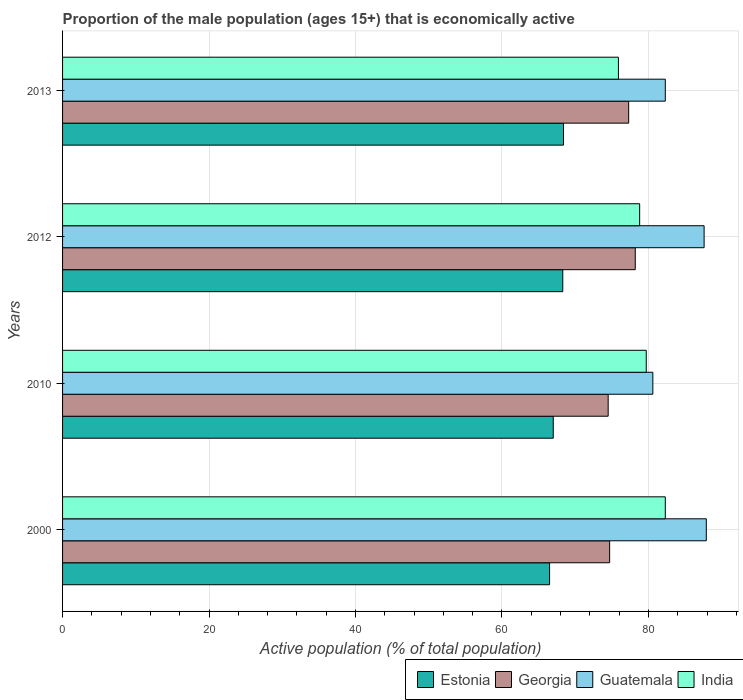How many groups of bars are there?
Provide a succinct answer. 4. Are the number of bars per tick equal to the number of legend labels?
Your response must be concise. Yes. Are the number of bars on each tick of the Y-axis equal?
Ensure brevity in your answer.  Yes. How many bars are there on the 3rd tick from the bottom?
Give a very brief answer. 4. What is the label of the 1st group of bars from the top?
Make the answer very short. 2013. What is the proportion of the male population that is economically active in India in 2012?
Offer a terse response. 78.8. Across all years, what is the maximum proportion of the male population that is economically active in India?
Offer a very short reply. 82.3. Across all years, what is the minimum proportion of the male population that is economically active in Estonia?
Keep it short and to the point. 66.5. What is the total proportion of the male population that is economically active in Georgia in the graph?
Keep it short and to the point. 304.7. What is the difference between the proportion of the male population that is economically active in Georgia in 2012 and that in 2013?
Provide a succinct answer. 0.9. What is the difference between the proportion of the male population that is economically active in India in 2010 and the proportion of the male population that is economically active in Georgia in 2013?
Your answer should be very brief. 2.4. What is the average proportion of the male population that is economically active in Guatemala per year?
Make the answer very short. 84.6. In the year 2013, what is the difference between the proportion of the male population that is economically active in Estonia and proportion of the male population that is economically active in India?
Keep it short and to the point. -7.5. In how many years, is the proportion of the male population that is economically active in Georgia greater than 44 %?
Make the answer very short. 4. What is the ratio of the proportion of the male population that is economically active in Georgia in 2000 to that in 2010?
Your response must be concise. 1. Is the proportion of the male population that is economically active in Guatemala in 2000 less than that in 2010?
Ensure brevity in your answer.  No. Is the difference between the proportion of the male population that is economically active in Estonia in 2012 and 2013 greater than the difference between the proportion of the male population that is economically active in India in 2012 and 2013?
Give a very brief answer. No. What is the difference between the highest and the second highest proportion of the male population that is economically active in Estonia?
Provide a short and direct response. 0.1. What is the difference between the highest and the lowest proportion of the male population that is economically active in India?
Provide a short and direct response. 6.4. In how many years, is the proportion of the male population that is economically active in Guatemala greater than the average proportion of the male population that is economically active in Guatemala taken over all years?
Give a very brief answer. 2. Is the sum of the proportion of the male population that is economically active in India in 2000 and 2013 greater than the maximum proportion of the male population that is economically active in Georgia across all years?
Give a very brief answer. Yes. Is it the case that in every year, the sum of the proportion of the male population that is economically active in Georgia and proportion of the male population that is economically active in Guatemala is greater than the sum of proportion of the male population that is economically active in India and proportion of the male population that is economically active in Estonia?
Your answer should be very brief. Yes. What does the 4th bar from the top in 2012 represents?
Give a very brief answer. Estonia. What does the 2nd bar from the bottom in 2010 represents?
Your answer should be compact. Georgia. Is it the case that in every year, the sum of the proportion of the male population that is economically active in Georgia and proportion of the male population that is economically active in Guatemala is greater than the proportion of the male population that is economically active in India?
Offer a terse response. Yes. Are all the bars in the graph horizontal?
Offer a very short reply. Yes. How many years are there in the graph?
Your response must be concise. 4. Are the values on the major ticks of X-axis written in scientific E-notation?
Your answer should be very brief. No. Does the graph contain any zero values?
Your answer should be compact. No. Where does the legend appear in the graph?
Offer a terse response. Bottom right. How are the legend labels stacked?
Provide a short and direct response. Horizontal. What is the title of the graph?
Offer a terse response. Proportion of the male population (ages 15+) that is economically active. Does "Egypt, Arab Rep." appear as one of the legend labels in the graph?
Provide a short and direct response. No. What is the label or title of the X-axis?
Ensure brevity in your answer.  Active population (% of total population). What is the label or title of the Y-axis?
Ensure brevity in your answer.  Years. What is the Active population (% of total population) of Estonia in 2000?
Provide a short and direct response. 66.5. What is the Active population (% of total population) of Georgia in 2000?
Give a very brief answer. 74.7. What is the Active population (% of total population) in Guatemala in 2000?
Your answer should be compact. 87.9. What is the Active population (% of total population) of India in 2000?
Keep it short and to the point. 82.3. What is the Active population (% of total population) of Estonia in 2010?
Offer a terse response. 67. What is the Active population (% of total population) of Georgia in 2010?
Offer a terse response. 74.5. What is the Active population (% of total population) of Guatemala in 2010?
Give a very brief answer. 80.6. What is the Active population (% of total population) in India in 2010?
Ensure brevity in your answer.  79.7. What is the Active population (% of total population) of Estonia in 2012?
Provide a succinct answer. 68.3. What is the Active population (% of total population) in Georgia in 2012?
Your answer should be compact. 78.2. What is the Active population (% of total population) of Guatemala in 2012?
Your answer should be very brief. 87.6. What is the Active population (% of total population) of India in 2012?
Offer a terse response. 78.8. What is the Active population (% of total population) in Estonia in 2013?
Give a very brief answer. 68.4. What is the Active population (% of total population) in Georgia in 2013?
Your answer should be compact. 77.3. What is the Active population (% of total population) in Guatemala in 2013?
Provide a short and direct response. 82.3. What is the Active population (% of total population) of India in 2013?
Your answer should be very brief. 75.9. Across all years, what is the maximum Active population (% of total population) of Estonia?
Your answer should be very brief. 68.4. Across all years, what is the maximum Active population (% of total population) in Georgia?
Your answer should be very brief. 78.2. Across all years, what is the maximum Active population (% of total population) in Guatemala?
Offer a terse response. 87.9. Across all years, what is the maximum Active population (% of total population) in India?
Make the answer very short. 82.3. Across all years, what is the minimum Active population (% of total population) of Estonia?
Your response must be concise. 66.5. Across all years, what is the minimum Active population (% of total population) of Georgia?
Provide a short and direct response. 74.5. Across all years, what is the minimum Active population (% of total population) of Guatemala?
Ensure brevity in your answer.  80.6. Across all years, what is the minimum Active population (% of total population) in India?
Your response must be concise. 75.9. What is the total Active population (% of total population) of Estonia in the graph?
Your answer should be very brief. 270.2. What is the total Active population (% of total population) in Georgia in the graph?
Offer a very short reply. 304.7. What is the total Active population (% of total population) of Guatemala in the graph?
Your answer should be very brief. 338.4. What is the total Active population (% of total population) of India in the graph?
Your response must be concise. 316.7. What is the difference between the Active population (% of total population) in Georgia in 2000 and that in 2010?
Give a very brief answer. 0.2. What is the difference between the Active population (% of total population) of Georgia in 2000 and that in 2013?
Keep it short and to the point. -2.6. What is the difference between the Active population (% of total population) in Guatemala in 2000 and that in 2013?
Provide a succinct answer. 5.6. What is the difference between the Active population (% of total population) in Estonia in 2010 and that in 2012?
Your answer should be very brief. -1.3. What is the difference between the Active population (% of total population) of India in 2010 and that in 2012?
Your response must be concise. 0.9. What is the difference between the Active population (% of total population) in Estonia in 2010 and that in 2013?
Ensure brevity in your answer.  -1.4. What is the difference between the Active population (% of total population) of Georgia in 2010 and that in 2013?
Offer a terse response. -2.8. What is the difference between the Active population (% of total population) of Estonia in 2012 and that in 2013?
Your response must be concise. -0.1. What is the difference between the Active population (% of total population) in Guatemala in 2012 and that in 2013?
Offer a terse response. 5.3. What is the difference between the Active population (% of total population) of India in 2012 and that in 2013?
Your answer should be compact. 2.9. What is the difference between the Active population (% of total population) of Estonia in 2000 and the Active population (% of total population) of Guatemala in 2010?
Your response must be concise. -14.1. What is the difference between the Active population (% of total population) of Georgia in 2000 and the Active population (% of total population) of Guatemala in 2010?
Make the answer very short. -5.9. What is the difference between the Active population (% of total population) of Guatemala in 2000 and the Active population (% of total population) of India in 2010?
Your answer should be very brief. 8.2. What is the difference between the Active population (% of total population) in Estonia in 2000 and the Active population (% of total population) in Georgia in 2012?
Ensure brevity in your answer.  -11.7. What is the difference between the Active population (% of total population) of Estonia in 2000 and the Active population (% of total population) of Guatemala in 2012?
Keep it short and to the point. -21.1. What is the difference between the Active population (% of total population) in Estonia in 2000 and the Active population (% of total population) in India in 2012?
Provide a succinct answer. -12.3. What is the difference between the Active population (% of total population) in Georgia in 2000 and the Active population (% of total population) in Guatemala in 2012?
Offer a terse response. -12.9. What is the difference between the Active population (% of total population) of Guatemala in 2000 and the Active population (% of total population) of India in 2012?
Keep it short and to the point. 9.1. What is the difference between the Active population (% of total population) in Estonia in 2000 and the Active population (% of total population) in Guatemala in 2013?
Offer a terse response. -15.8. What is the difference between the Active population (% of total population) of Georgia in 2000 and the Active population (% of total population) of Guatemala in 2013?
Offer a very short reply. -7.6. What is the difference between the Active population (% of total population) of Georgia in 2000 and the Active population (% of total population) of India in 2013?
Keep it short and to the point. -1.2. What is the difference between the Active population (% of total population) of Guatemala in 2000 and the Active population (% of total population) of India in 2013?
Your answer should be very brief. 12. What is the difference between the Active population (% of total population) of Estonia in 2010 and the Active population (% of total population) of Georgia in 2012?
Ensure brevity in your answer.  -11.2. What is the difference between the Active population (% of total population) in Estonia in 2010 and the Active population (% of total population) in Guatemala in 2012?
Give a very brief answer. -20.6. What is the difference between the Active population (% of total population) of Estonia in 2010 and the Active population (% of total population) of India in 2012?
Make the answer very short. -11.8. What is the difference between the Active population (% of total population) in Georgia in 2010 and the Active population (% of total population) in Guatemala in 2012?
Your answer should be compact. -13.1. What is the difference between the Active population (% of total population) in Estonia in 2010 and the Active population (% of total population) in Guatemala in 2013?
Keep it short and to the point. -15.3. What is the difference between the Active population (% of total population) in Georgia in 2010 and the Active population (% of total population) in Guatemala in 2013?
Your answer should be compact. -7.8. What is the difference between the Active population (% of total population) of Georgia in 2010 and the Active population (% of total population) of India in 2013?
Make the answer very short. -1.4. What is the difference between the Active population (% of total population) in Guatemala in 2010 and the Active population (% of total population) in India in 2013?
Offer a very short reply. 4.7. What is the difference between the Active population (% of total population) in Estonia in 2012 and the Active population (% of total population) in Georgia in 2013?
Make the answer very short. -9. What is the difference between the Active population (% of total population) in Estonia in 2012 and the Active population (% of total population) in India in 2013?
Offer a very short reply. -7.6. What is the difference between the Active population (% of total population) of Georgia in 2012 and the Active population (% of total population) of India in 2013?
Your response must be concise. 2.3. What is the average Active population (% of total population) in Estonia per year?
Your answer should be compact. 67.55. What is the average Active population (% of total population) in Georgia per year?
Offer a very short reply. 76.17. What is the average Active population (% of total population) of Guatemala per year?
Your response must be concise. 84.6. What is the average Active population (% of total population) in India per year?
Offer a terse response. 79.17. In the year 2000, what is the difference between the Active population (% of total population) of Estonia and Active population (% of total population) of Georgia?
Ensure brevity in your answer.  -8.2. In the year 2000, what is the difference between the Active population (% of total population) of Estonia and Active population (% of total population) of Guatemala?
Make the answer very short. -21.4. In the year 2000, what is the difference between the Active population (% of total population) of Estonia and Active population (% of total population) of India?
Give a very brief answer. -15.8. In the year 2000, what is the difference between the Active population (% of total population) in Guatemala and Active population (% of total population) in India?
Your answer should be very brief. 5.6. In the year 2010, what is the difference between the Active population (% of total population) in Estonia and Active population (% of total population) in Guatemala?
Your response must be concise. -13.6. In the year 2010, what is the difference between the Active population (% of total population) of Georgia and Active population (% of total population) of India?
Offer a very short reply. -5.2. In the year 2012, what is the difference between the Active population (% of total population) of Estonia and Active population (% of total population) of Georgia?
Provide a succinct answer. -9.9. In the year 2012, what is the difference between the Active population (% of total population) of Estonia and Active population (% of total population) of Guatemala?
Offer a terse response. -19.3. In the year 2012, what is the difference between the Active population (% of total population) of Estonia and Active population (% of total population) of India?
Make the answer very short. -10.5. In the year 2012, what is the difference between the Active population (% of total population) of Georgia and Active population (% of total population) of India?
Your response must be concise. -0.6. In the year 2012, what is the difference between the Active population (% of total population) in Guatemala and Active population (% of total population) in India?
Provide a succinct answer. 8.8. In the year 2013, what is the difference between the Active population (% of total population) in Estonia and Active population (% of total population) in Guatemala?
Offer a very short reply. -13.9. In the year 2013, what is the difference between the Active population (% of total population) of Estonia and Active population (% of total population) of India?
Provide a succinct answer. -7.5. In the year 2013, what is the difference between the Active population (% of total population) in Georgia and Active population (% of total population) in Guatemala?
Your answer should be compact. -5. In the year 2013, what is the difference between the Active population (% of total population) of Georgia and Active population (% of total population) of India?
Provide a succinct answer. 1.4. In the year 2013, what is the difference between the Active population (% of total population) in Guatemala and Active population (% of total population) in India?
Make the answer very short. 6.4. What is the ratio of the Active population (% of total population) in Estonia in 2000 to that in 2010?
Your answer should be very brief. 0.99. What is the ratio of the Active population (% of total population) of Georgia in 2000 to that in 2010?
Give a very brief answer. 1. What is the ratio of the Active population (% of total population) of Guatemala in 2000 to that in 2010?
Offer a terse response. 1.09. What is the ratio of the Active population (% of total population) in India in 2000 to that in 2010?
Your response must be concise. 1.03. What is the ratio of the Active population (% of total population) in Estonia in 2000 to that in 2012?
Make the answer very short. 0.97. What is the ratio of the Active population (% of total population) of Georgia in 2000 to that in 2012?
Your response must be concise. 0.96. What is the ratio of the Active population (% of total population) of India in 2000 to that in 2012?
Your response must be concise. 1.04. What is the ratio of the Active population (% of total population) of Estonia in 2000 to that in 2013?
Your answer should be very brief. 0.97. What is the ratio of the Active population (% of total population) in Georgia in 2000 to that in 2013?
Give a very brief answer. 0.97. What is the ratio of the Active population (% of total population) in Guatemala in 2000 to that in 2013?
Keep it short and to the point. 1.07. What is the ratio of the Active population (% of total population) in India in 2000 to that in 2013?
Offer a terse response. 1.08. What is the ratio of the Active population (% of total population) of Georgia in 2010 to that in 2012?
Offer a terse response. 0.95. What is the ratio of the Active population (% of total population) in Guatemala in 2010 to that in 2012?
Give a very brief answer. 0.92. What is the ratio of the Active population (% of total population) of India in 2010 to that in 2012?
Keep it short and to the point. 1.01. What is the ratio of the Active population (% of total population) of Estonia in 2010 to that in 2013?
Provide a succinct answer. 0.98. What is the ratio of the Active population (% of total population) in Georgia in 2010 to that in 2013?
Provide a short and direct response. 0.96. What is the ratio of the Active population (% of total population) of Guatemala in 2010 to that in 2013?
Your answer should be very brief. 0.98. What is the ratio of the Active population (% of total population) of India in 2010 to that in 2013?
Offer a terse response. 1.05. What is the ratio of the Active population (% of total population) in Georgia in 2012 to that in 2013?
Your answer should be very brief. 1.01. What is the ratio of the Active population (% of total population) of Guatemala in 2012 to that in 2013?
Provide a succinct answer. 1.06. What is the ratio of the Active population (% of total population) of India in 2012 to that in 2013?
Your answer should be compact. 1.04. What is the difference between the highest and the second highest Active population (% of total population) of Estonia?
Your answer should be compact. 0.1. What is the difference between the highest and the second highest Active population (% of total population) of Georgia?
Make the answer very short. 0.9. What is the difference between the highest and the second highest Active population (% of total population) of Guatemala?
Make the answer very short. 0.3. What is the difference between the highest and the lowest Active population (% of total population) of Georgia?
Your response must be concise. 3.7. What is the difference between the highest and the lowest Active population (% of total population) of Guatemala?
Provide a short and direct response. 7.3. What is the difference between the highest and the lowest Active population (% of total population) in India?
Your response must be concise. 6.4. 